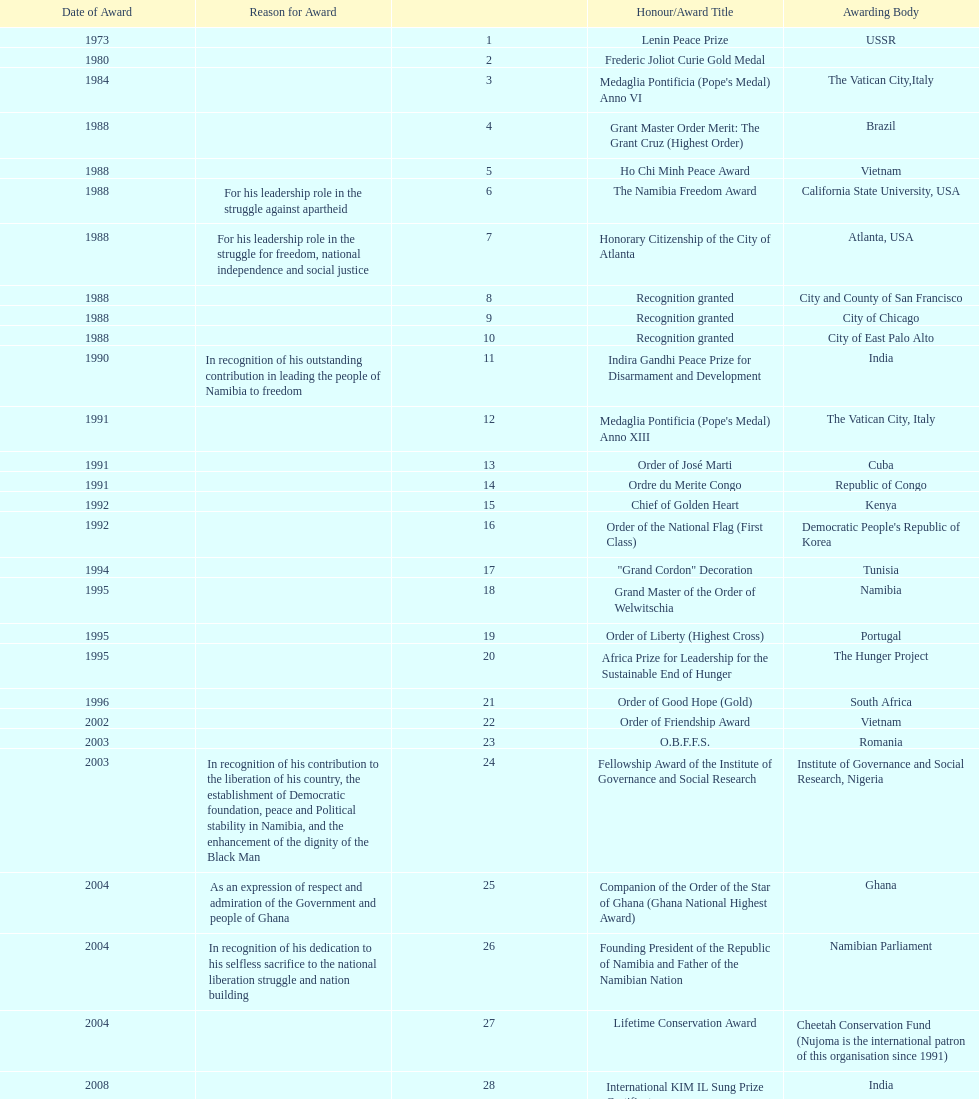The number of times "recognition granted" was the received award? 3. 